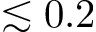<formula> <loc_0><loc_0><loc_500><loc_500>\lesssim 0 . 2</formula> 